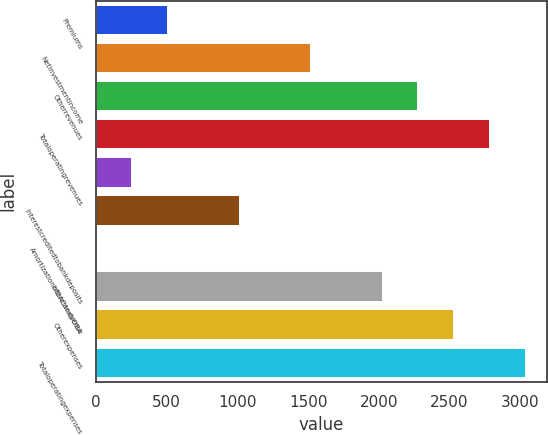<chart> <loc_0><loc_0><loc_500><loc_500><bar_chart><fcel>Premiums<fcel>Netinvestmentincome<fcel>Otherrevenues<fcel>Totaloperatingrevenues<fcel>Unnamed: 4<fcel>Interestcreditedtobankdeposits<fcel>AmortizationofDACandVOBA<fcel>Interestexpense<fcel>Otherexpenses<fcel>Totaloperatingexpenses<nl><fcel>509<fcel>1521<fcel>2280<fcel>2786<fcel>256<fcel>1015<fcel>3<fcel>2027<fcel>2533<fcel>3039<nl></chart> 